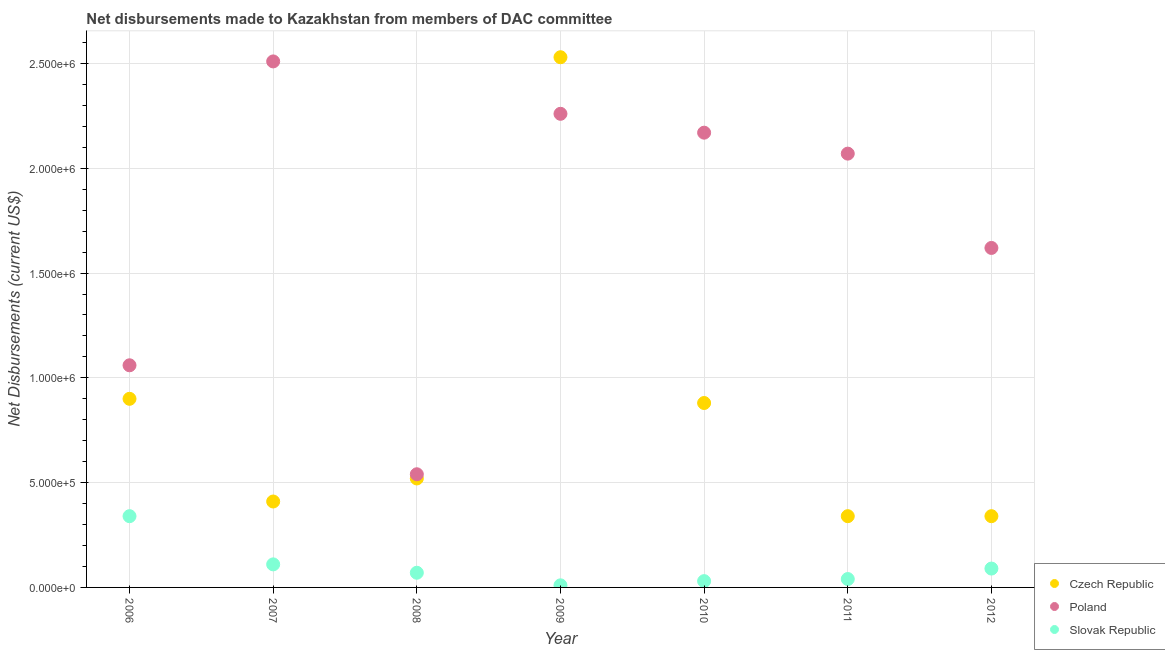How many different coloured dotlines are there?
Ensure brevity in your answer.  3. Is the number of dotlines equal to the number of legend labels?
Your answer should be very brief. Yes. What is the net disbursements made by poland in 2011?
Give a very brief answer. 2.07e+06. Across all years, what is the maximum net disbursements made by czech republic?
Make the answer very short. 2.53e+06. Across all years, what is the minimum net disbursements made by slovak republic?
Ensure brevity in your answer.  10000. In which year was the net disbursements made by czech republic maximum?
Offer a very short reply. 2009. In which year was the net disbursements made by poland minimum?
Your response must be concise. 2008. What is the total net disbursements made by czech republic in the graph?
Make the answer very short. 5.92e+06. What is the difference between the net disbursements made by poland in 2007 and that in 2010?
Your answer should be compact. 3.40e+05. What is the difference between the net disbursements made by czech republic in 2006 and the net disbursements made by poland in 2008?
Offer a terse response. 3.60e+05. What is the average net disbursements made by czech republic per year?
Offer a terse response. 8.46e+05. In the year 2011, what is the difference between the net disbursements made by slovak republic and net disbursements made by poland?
Ensure brevity in your answer.  -2.03e+06. What is the ratio of the net disbursements made by poland in 2007 to that in 2008?
Offer a very short reply. 4.65. Is the net disbursements made by slovak republic in 2007 less than that in 2009?
Keep it short and to the point. No. Is the difference between the net disbursements made by slovak republic in 2008 and 2012 greater than the difference between the net disbursements made by poland in 2008 and 2012?
Ensure brevity in your answer.  Yes. What is the difference between the highest and the second highest net disbursements made by czech republic?
Make the answer very short. 1.63e+06. What is the difference between the highest and the lowest net disbursements made by czech republic?
Ensure brevity in your answer.  2.19e+06. In how many years, is the net disbursements made by poland greater than the average net disbursements made by poland taken over all years?
Keep it short and to the point. 4. Is it the case that in every year, the sum of the net disbursements made by czech republic and net disbursements made by poland is greater than the net disbursements made by slovak republic?
Your answer should be compact. Yes. Does the net disbursements made by slovak republic monotonically increase over the years?
Your response must be concise. No. How many years are there in the graph?
Provide a succinct answer. 7. Are the values on the major ticks of Y-axis written in scientific E-notation?
Offer a terse response. Yes. Does the graph contain grids?
Keep it short and to the point. Yes. How are the legend labels stacked?
Keep it short and to the point. Vertical. What is the title of the graph?
Your response must be concise. Net disbursements made to Kazakhstan from members of DAC committee. Does "Ages 20-60" appear as one of the legend labels in the graph?
Your answer should be compact. No. What is the label or title of the X-axis?
Offer a very short reply. Year. What is the label or title of the Y-axis?
Your answer should be very brief. Net Disbursements (current US$). What is the Net Disbursements (current US$) of Czech Republic in 2006?
Keep it short and to the point. 9.00e+05. What is the Net Disbursements (current US$) of Poland in 2006?
Make the answer very short. 1.06e+06. What is the Net Disbursements (current US$) of Slovak Republic in 2006?
Provide a short and direct response. 3.40e+05. What is the Net Disbursements (current US$) of Czech Republic in 2007?
Your answer should be very brief. 4.10e+05. What is the Net Disbursements (current US$) in Poland in 2007?
Offer a terse response. 2.51e+06. What is the Net Disbursements (current US$) in Slovak Republic in 2007?
Ensure brevity in your answer.  1.10e+05. What is the Net Disbursements (current US$) in Czech Republic in 2008?
Give a very brief answer. 5.20e+05. What is the Net Disbursements (current US$) in Poland in 2008?
Your answer should be compact. 5.40e+05. What is the Net Disbursements (current US$) of Czech Republic in 2009?
Offer a terse response. 2.53e+06. What is the Net Disbursements (current US$) of Poland in 2009?
Your answer should be very brief. 2.26e+06. What is the Net Disbursements (current US$) of Czech Republic in 2010?
Your response must be concise. 8.80e+05. What is the Net Disbursements (current US$) in Poland in 2010?
Your response must be concise. 2.17e+06. What is the Net Disbursements (current US$) in Slovak Republic in 2010?
Your answer should be compact. 3.00e+04. What is the Net Disbursements (current US$) in Poland in 2011?
Offer a terse response. 2.07e+06. What is the Net Disbursements (current US$) in Czech Republic in 2012?
Offer a terse response. 3.40e+05. What is the Net Disbursements (current US$) in Poland in 2012?
Offer a very short reply. 1.62e+06. Across all years, what is the maximum Net Disbursements (current US$) in Czech Republic?
Offer a terse response. 2.53e+06. Across all years, what is the maximum Net Disbursements (current US$) of Poland?
Offer a very short reply. 2.51e+06. Across all years, what is the maximum Net Disbursements (current US$) in Slovak Republic?
Your response must be concise. 3.40e+05. Across all years, what is the minimum Net Disbursements (current US$) in Poland?
Offer a terse response. 5.40e+05. What is the total Net Disbursements (current US$) in Czech Republic in the graph?
Offer a very short reply. 5.92e+06. What is the total Net Disbursements (current US$) of Poland in the graph?
Your response must be concise. 1.22e+07. What is the total Net Disbursements (current US$) in Slovak Republic in the graph?
Provide a succinct answer. 6.90e+05. What is the difference between the Net Disbursements (current US$) of Czech Republic in 2006 and that in 2007?
Your answer should be compact. 4.90e+05. What is the difference between the Net Disbursements (current US$) in Poland in 2006 and that in 2007?
Make the answer very short. -1.45e+06. What is the difference between the Net Disbursements (current US$) of Poland in 2006 and that in 2008?
Give a very brief answer. 5.20e+05. What is the difference between the Net Disbursements (current US$) in Czech Republic in 2006 and that in 2009?
Offer a terse response. -1.63e+06. What is the difference between the Net Disbursements (current US$) of Poland in 2006 and that in 2009?
Your response must be concise. -1.20e+06. What is the difference between the Net Disbursements (current US$) of Czech Republic in 2006 and that in 2010?
Make the answer very short. 2.00e+04. What is the difference between the Net Disbursements (current US$) in Poland in 2006 and that in 2010?
Offer a terse response. -1.11e+06. What is the difference between the Net Disbursements (current US$) in Czech Republic in 2006 and that in 2011?
Provide a succinct answer. 5.60e+05. What is the difference between the Net Disbursements (current US$) in Poland in 2006 and that in 2011?
Offer a terse response. -1.01e+06. What is the difference between the Net Disbursements (current US$) in Slovak Republic in 2006 and that in 2011?
Your answer should be compact. 3.00e+05. What is the difference between the Net Disbursements (current US$) in Czech Republic in 2006 and that in 2012?
Keep it short and to the point. 5.60e+05. What is the difference between the Net Disbursements (current US$) in Poland in 2006 and that in 2012?
Ensure brevity in your answer.  -5.60e+05. What is the difference between the Net Disbursements (current US$) in Poland in 2007 and that in 2008?
Your answer should be very brief. 1.97e+06. What is the difference between the Net Disbursements (current US$) in Slovak Republic in 2007 and that in 2008?
Offer a terse response. 4.00e+04. What is the difference between the Net Disbursements (current US$) of Czech Republic in 2007 and that in 2009?
Keep it short and to the point. -2.12e+06. What is the difference between the Net Disbursements (current US$) in Poland in 2007 and that in 2009?
Ensure brevity in your answer.  2.50e+05. What is the difference between the Net Disbursements (current US$) of Slovak Republic in 2007 and that in 2009?
Your response must be concise. 1.00e+05. What is the difference between the Net Disbursements (current US$) in Czech Republic in 2007 and that in 2010?
Make the answer very short. -4.70e+05. What is the difference between the Net Disbursements (current US$) in Poland in 2007 and that in 2010?
Keep it short and to the point. 3.40e+05. What is the difference between the Net Disbursements (current US$) of Slovak Republic in 2007 and that in 2010?
Offer a very short reply. 8.00e+04. What is the difference between the Net Disbursements (current US$) of Czech Republic in 2007 and that in 2011?
Provide a short and direct response. 7.00e+04. What is the difference between the Net Disbursements (current US$) in Poland in 2007 and that in 2012?
Your response must be concise. 8.90e+05. What is the difference between the Net Disbursements (current US$) of Czech Republic in 2008 and that in 2009?
Keep it short and to the point. -2.01e+06. What is the difference between the Net Disbursements (current US$) in Poland in 2008 and that in 2009?
Your answer should be compact. -1.72e+06. What is the difference between the Net Disbursements (current US$) of Slovak Republic in 2008 and that in 2009?
Make the answer very short. 6.00e+04. What is the difference between the Net Disbursements (current US$) of Czech Republic in 2008 and that in 2010?
Give a very brief answer. -3.60e+05. What is the difference between the Net Disbursements (current US$) of Poland in 2008 and that in 2010?
Provide a short and direct response. -1.63e+06. What is the difference between the Net Disbursements (current US$) in Czech Republic in 2008 and that in 2011?
Keep it short and to the point. 1.80e+05. What is the difference between the Net Disbursements (current US$) of Poland in 2008 and that in 2011?
Provide a short and direct response. -1.53e+06. What is the difference between the Net Disbursements (current US$) of Czech Republic in 2008 and that in 2012?
Your answer should be very brief. 1.80e+05. What is the difference between the Net Disbursements (current US$) of Poland in 2008 and that in 2012?
Provide a short and direct response. -1.08e+06. What is the difference between the Net Disbursements (current US$) in Slovak Republic in 2008 and that in 2012?
Ensure brevity in your answer.  -2.00e+04. What is the difference between the Net Disbursements (current US$) of Czech Republic in 2009 and that in 2010?
Offer a very short reply. 1.65e+06. What is the difference between the Net Disbursements (current US$) in Poland in 2009 and that in 2010?
Offer a terse response. 9.00e+04. What is the difference between the Net Disbursements (current US$) in Slovak Republic in 2009 and that in 2010?
Provide a short and direct response. -2.00e+04. What is the difference between the Net Disbursements (current US$) in Czech Republic in 2009 and that in 2011?
Give a very brief answer. 2.19e+06. What is the difference between the Net Disbursements (current US$) in Czech Republic in 2009 and that in 2012?
Offer a terse response. 2.19e+06. What is the difference between the Net Disbursements (current US$) in Poland in 2009 and that in 2012?
Offer a terse response. 6.40e+05. What is the difference between the Net Disbursements (current US$) in Czech Republic in 2010 and that in 2011?
Offer a terse response. 5.40e+05. What is the difference between the Net Disbursements (current US$) of Czech Republic in 2010 and that in 2012?
Your answer should be very brief. 5.40e+05. What is the difference between the Net Disbursements (current US$) in Slovak Republic in 2010 and that in 2012?
Your response must be concise. -6.00e+04. What is the difference between the Net Disbursements (current US$) of Poland in 2011 and that in 2012?
Give a very brief answer. 4.50e+05. What is the difference between the Net Disbursements (current US$) of Czech Republic in 2006 and the Net Disbursements (current US$) of Poland in 2007?
Your answer should be compact. -1.61e+06. What is the difference between the Net Disbursements (current US$) in Czech Republic in 2006 and the Net Disbursements (current US$) in Slovak Republic in 2007?
Give a very brief answer. 7.90e+05. What is the difference between the Net Disbursements (current US$) in Poland in 2006 and the Net Disbursements (current US$) in Slovak Republic in 2007?
Provide a short and direct response. 9.50e+05. What is the difference between the Net Disbursements (current US$) of Czech Republic in 2006 and the Net Disbursements (current US$) of Slovak Republic in 2008?
Keep it short and to the point. 8.30e+05. What is the difference between the Net Disbursements (current US$) of Poland in 2006 and the Net Disbursements (current US$) of Slovak Republic in 2008?
Offer a very short reply. 9.90e+05. What is the difference between the Net Disbursements (current US$) of Czech Republic in 2006 and the Net Disbursements (current US$) of Poland in 2009?
Give a very brief answer. -1.36e+06. What is the difference between the Net Disbursements (current US$) of Czech Republic in 2006 and the Net Disbursements (current US$) of Slovak Republic in 2009?
Make the answer very short. 8.90e+05. What is the difference between the Net Disbursements (current US$) in Poland in 2006 and the Net Disbursements (current US$) in Slovak Republic in 2009?
Your answer should be compact. 1.05e+06. What is the difference between the Net Disbursements (current US$) in Czech Republic in 2006 and the Net Disbursements (current US$) in Poland in 2010?
Your answer should be compact. -1.27e+06. What is the difference between the Net Disbursements (current US$) of Czech Republic in 2006 and the Net Disbursements (current US$) of Slovak Republic in 2010?
Give a very brief answer. 8.70e+05. What is the difference between the Net Disbursements (current US$) in Poland in 2006 and the Net Disbursements (current US$) in Slovak Republic in 2010?
Offer a very short reply. 1.03e+06. What is the difference between the Net Disbursements (current US$) of Czech Republic in 2006 and the Net Disbursements (current US$) of Poland in 2011?
Offer a terse response. -1.17e+06. What is the difference between the Net Disbursements (current US$) of Czech Republic in 2006 and the Net Disbursements (current US$) of Slovak Republic in 2011?
Your answer should be compact. 8.60e+05. What is the difference between the Net Disbursements (current US$) of Poland in 2006 and the Net Disbursements (current US$) of Slovak Republic in 2011?
Offer a terse response. 1.02e+06. What is the difference between the Net Disbursements (current US$) in Czech Republic in 2006 and the Net Disbursements (current US$) in Poland in 2012?
Provide a short and direct response. -7.20e+05. What is the difference between the Net Disbursements (current US$) of Czech Republic in 2006 and the Net Disbursements (current US$) of Slovak Republic in 2012?
Provide a succinct answer. 8.10e+05. What is the difference between the Net Disbursements (current US$) of Poland in 2006 and the Net Disbursements (current US$) of Slovak Republic in 2012?
Provide a succinct answer. 9.70e+05. What is the difference between the Net Disbursements (current US$) in Czech Republic in 2007 and the Net Disbursements (current US$) in Poland in 2008?
Ensure brevity in your answer.  -1.30e+05. What is the difference between the Net Disbursements (current US$) in Poland in 2007 and the Net Disbursements (current US$) in Slovak Republic in 2008?
Your response must be concise. 2.44e+06. What is the difference between the Net Disbursements (current US$) in Czech Republic in 2007 and the Net Disbursements (current US$) in Poland in 2009?
Give a very brief answer. -1.85e+06. What is the difference between the Net Disbursements (current US$) of Poland in 2007 and the Net Disbursements (current US$) of Slovak Republic in 2009?
Provide a succinct answer. 2.50e+06. What is the difference between the Net Disbursements (current US$) of Czech Republic in 2007 and the Net Disbursements (current US$) of Poland in 2010?
Make the answer very short. -1.76e+06. What is the difference between the Net Disbursements (current US$) of Czech Republic in 2007 and the Net Disbursements (current US$) of Slovak Republic in 2010?
Your response must be concise. 3.80e+05. What is the difference between the Net Disbursements (current US$) of Poland in 2007 and the Net Disbursements (current US$) of Slovak Republic in 2010?
Provide a succinct answer. 2.48e+06. What is the difference between the Net Disbursements (current US$) of Czech Republic in 2007 and the Net Disbursements (current US$) of Poland in 2011?
Provide a short and direct response. -1.66e+06. What is the difference between the Net Disbursements (current US$) in Poland in 2007 and the Net Disbursements (current US$) in Slovak Republic in 2011?
Offer a terse response. 2.47e+06. What is the difference between the Net Disbursements (current US$) in Czech Republic in 2007 and the Net Disbursements (current US$) in Poland in 2012?
Your response must be concise. -1.21e+06. What is the difference between the Net Disbursements (current US$) of Poland in 2007 and the Net Disbursements (current US$) of Slovak Republic in 2012?
Offer a very short reply. 2.42e+06. What is the difference between the Net Disbursements (current US$) of Czech Republic in 2008 and the Net Disbursements (current US$) of Poland in 2009?
Provide a succinct answer. -1.74e+06. What is the difference between the Net Disbursements (current US$) in Czech Republic in 2008 and the Net Disbursements (current US$) in Slovak Republic in 2009?
Provide a short and direct response. 5.10e+05. What is the difference between the Net Disbursements (current US$) of Poland in 2008 and the Net Disbursements (current US$) of Slovak Republic in 2009?
Give a very brief answer. 5.30e+05. What is the difference between the Net Disbursements (current US$) in Czech Republic in 2008 and the Net Disbursements (current US$) in Poland in 2010?
Provide a short and direct response. -1.65e+06. What is the difference between the Net Disbursements (current US$) in Poland in 2008 and the Net Disbursements (current US$) in Slovak Republic in 2010?
Give a very brief answer. 5.10e+05. What is the difference between the Net Disbursements (current US$) in Czech Republic in 2008 and the Net Disbursements (current US$) in Poland in 2011?
Make the answer very short. -1.55e+06. What is the difference between the Net Disbursements (current US$) in Czech Republic in 2008 and the Net Disbursements (current US$) in Poland in 2012?
Your answer should be very brief. -1.10e+06. What is the difference between the Net Disbursements (current US$) of Czech Republic in 2008 and the Net Disbursements (current US$) of Slovak Republic in 2012?
Ensure brevity in your answer.  4.30e+05. What is the difference between the Net Disbursements (current US$) of Poland in 2008 and the Net Disbursements (current US$) of Slovak Republic in 2012?
Keep it short and to the point. 4.50e+05. What is the difference between the Net Disbursements (current US$) of Czech Republic in 2009 and the Net Disbursements (current US$) of Poland in 2010?
Offer a terse response. 3.60e+05. What is the difference between the Net Disbursements (current US$) of Czech Republic in 2009 and the Net Disbursements (current US$) of Slovak Republic in 2010?
Offer a terse response. 2.50e+06. What is the difference between the Net Disbursements (current US$) of Poland in 2009 and the Net Disbursements (current US$) of Slovak Republic in 2010?
Provide a succinct answer. 2.23e+06. What is the difference between the Net Disbursements (current US$) of Czech Republic in 2009 and the Net Disbursements (current US$) of Poland in 2011?
Offer a very short reply. 4.60e+05. What is the difference between the Net Disbursements (current US$) in Czech Republic in 2009 and the Net Disbursements (current US$) in Slovak Republic in 2011?
Offer a terse response. 2.49e+06. What is the difference between the Net Disbursements (current US$) in Poland in 2009 and the Net Disbursements (current US$) in Slovak Republic in 2011?
Provide a succinct answer. 2.22e+06. What is the difference between the Net Disbursements (current US$) of Czech Republic in 2009 and the Net Disbursements (current US$) of Poland in 2012?
Make the answer very short. 9.10e+05. What is the difference between the Net Disbursements (current US$) of Czech Republic in 2009 and the Net Disbursements (current US$) of Slovak Republic in 2012?
Make the answer very short. 2.44e+06. What is the difference between the Net Disbursements (current US$) of Poland in 2009 and the Net Disbursements (current US$) of Slovak Republic in 2012?
Make the answer very short. 2.17e+06. What is the difference between the Net Disbursements (current US$) in Czech Republic in 2010 and the Net Disbursements (current US$) in Poland in 2011?
Your answer should be very brief. -1.19e+06. What is the difference between the Net Disbursements (current US$) of Czech Republic in 2010 and the Net Disbursements (current US$) of Slovak Republic in 2011?
Give a very brief answer. 8.40e+05. What is the difference between the Net Disbursements (current US$) in Poland in 2010 and the Net Disbursements (current US$) in Slovak Republic in 2011?
Make the answer very short. 2.13e+06. What is the difference between the Net Disbursements (current US$) of Czech Republic in 2010 and the Net Disbursements (current US$) of Poland in 2012?
Your answer should be very brief. -7.40e+05. What is the difference between the Net Disbursements (current US$) of Czech Republic in 2010 and the Net Disbursements (current US$) of Slovak Republic in 2012?
Your answer should be very brief. 7.90e+05. What is the difference between the Net Disbursements (current US$) in Poland in 2010 and the Net Disbursements (current US$) in Slovak Republic in 2012?
Your answer should be compact. 2.08e+06. What is the difference between the Net Disbursements (current US$) in Czech Republic in 2011 and the Net Disbursements (current US$) in Poland in 2012?
Ensure brevity in your answer.  -1.28e+06. What is the difference between the Net Disbursements (current US$) of Czech Republic in 2011 and the Net Disbursements (current US$) of Slovak Republic in 2012?
Your answer should be compact. 2.50e+05. What is the difference between the Net Disbursements (current US$) in Poland in 2011 and the Net Disbursements (current US$) in Slovak Republic in 2012?
Ensure brevity in your answer.  1.98e+06. What is the average Net Disbursements (current US$) of Czech Republic per year?
Provide a succinct answer. 8.46e+05. What is the average Net Disbursements (current US$) of Poland per year?
Offer a terse response. 1.75e+06. What is the average Net Disbursements (current US$) of Slovak Republic per year?
Your answer should be very brief. 9.86e+04. In the year 2006, what is the difference between the Net Disbursements (current US$) of Czech Republic and Net Disbursements (current US$) of Slovak Republic?
Your answer should be very brief. 5.60e+05. In the year 2006, what is the difference between the Net Disbursements (current US$) in Poland and Net Disbursements (current US$) in Slovak Republic?
Keep it short and to the point. 7.20e+05. In the year 2007, what is the difference between the Net Disbursements (current US$) of Czech Republic and Net Disbursements (current US$) of Poland?
Offer a very short reply. -2.10e+06. In the year 2007, what is the difference between the Net Disbursements (current US$) of Poland and Net Disbursements (current US$) of Slovak Republic?
Provide a succinct answer. 2.40e+06. In the year 2008, what is the difference between the Net Disbursements (current US$) of Czech Republic and Net Disbursements (current US$) of Slovak Republic?
Your answer should be compact. 4.50e+05. In the year 2008, what is the difference between the Net Disbursements (current US$) of Poland and Net Disbursements (current US$) of Slovak Republic?
Offer a very short reply. 4.70e+05. In the year 2009, what is the difference between the Net Disbursements (current US$) in Czech Republic and Net Disbursements (current US$) in Slovak Republic?
Offer a very short reply. 2.52e+06. In the year 2009, what is the difference between the Net Disbursements (current US$) of Poland and Net Disbursements (current US$) of Slovak Republic?
Your answer should be very brief. 2.25e+06. In the year 2010, what is the difference between the Net Disbursements (current US$) of Czech Republic and Net Disbursements (current US$) of Poland?
Provide a short and direct response. -1.29e+06. In the year 2010, what is the difference between the Net Disbursements (current US$) of Czech Republic and Net Disbursements (current US$) of Slovak Republic?
Ensure brevity in your answer.  8.50e+05. In the year 2010, what is the difference between the Net Disbursements (current US$) of Poland and Net Disbursements (current US$) of Slovak Republic?
Ensure brevity in your answer.  2.14e+06. In the year 2011, what is the difference between the Net Disbursements (current US$) of Czech Republic and Net Disbursements (current US$) of Poland?
Make the answer very short. -1.73e+06. In the year 2011, what is the difference between the Net Disbursements (current US$) of Poland and Net Disbursements (current US$) of Slovak Republic?
Make the answer very short. 2.03e+06. In the year 2012, what is the difference between the Net Disbursements (current US$) in Czech Republic and Net Disbursements (current US$) in Poland?
Keep it short and to the point. -1.28e+06. In the year 2012, what is the difference between the Net Disbursements (current US$) in Poland and Net Disbursements (current US$) in Slovak Republic?
Your response must be concise. 1.53e+06. What is the ratio of the Net Disbursements (current US$) in Czech Republic in 2006 to that in 2007?
Your answer should be very brief. 2.2. What is the ratio of the Net Disbursements (current US$) in Poland in 2006 to that in 2007?
Ensure brevity in your answer.  0.42. What is the ratio of the Net Disbursements (current US$) of Slovak Republic in 2006 to that in 2007?
Offer a terse response. 3.09. What is the ratio of the Net Disbursements (current US$) in Czech Republic in 2006 to that in 2008?
Provide a short and direct response. 1.73. What is the ratio of the Net Disbursements (current US$) in Poland in 2006 to that in 2008?
Your answer should be very brief. 1.96. What is the ratio of the Net Disbursements (current US$) of Slovak Republic in 2006 to that in 2008?
Your answer should be very brief. 4.86. What is the ratio of the Net Disbursements (current US$) in Czech Republic in 2006 to that in 2009?
Your answer should be very brief. 0.36. What is the ratio of the Net Disbursements (current US$) in Poland in 2006 to that in 2009?
Offer a very short reply. 0.47. What is the ratio of the Net Disbursements (current US$) in Slovak Republic in 2006 to that in 2009?
Give a very brief answer. 34. What is the ratio of the Net Disbursements (current US$) in Czech Republic in 2006 to that in 2010?
Make the answer very short. 1.02. What is the ratio of the Net Disbursements (current US$) of Poland in 2006 to that in 2010?
Make the answer very short. 0.49. What is the ratio of the Net Disbursements (current US$) in Slovak Republic in 2006 to that in 2010?
Give a very brief answer. 11.33. What is the ratio of the Net Disbursements (current US$) of Czech Republic in 2006 to that in 2011?
Make the answer very short. 2.65. What is the ratio of the Net Disbursements (current US$) in Poland in 2006 to that in 2011?
Offer a terse response. 0.51. What is the ratio of the Net Disbursements (current US$) in Slovak Republic in 2006 to that in 2011?
Ensure brevity in your answer.  8.5. What is the ratio of the Net Disbursements (current US$) of Czech Republic in 2006 to that in 2012?
Provide a succinct answer. 2.65. What is the ratio of the Net Disbursements (current US$) of Poland in 2006 to that in 2012?
Provide a succinct answer. 0.65. What is the ratio of the Net Disbursements (current US$) of Slovak Republic in 2006 to that in 2012?
Make the answer very short. 3.78. What is the ratio of the Net Disbursements (current US$) in Czech Republic in 2007 to that in 2008?
Give a very brief answer. 0.79. What is the ratio of the Net Disbursements (current US$) of Poland in 2007 to that in 2008?
Give a very brief answer. 4.65. What is the ratio of the Net Disbursements (current US$) of Slovak Republic in 2007 to that in 2008?
Your answer should be very brief. 1.57. What is the ratio of the Net Disbursements (current US$) in Czech Republic in 2007 to that in 2009?
Provide a succinct answer. 0.16. What is the ratio of the Net Disbursements (current US$) of Poland in 2007 to that in 2009?
Your answer should be very brief. 1.11. What is the ratio of the Net Disbursements (current US$) in Slovak Republic in 2007 to that in 2009?
Your answer should be very brief. 11. What is the ratio of the Net Disbursements (current US$) in Czech Republic in 2007 to that in 2010?
Offer a terse response. 0.47. What is the ratio of the Net Disbursements (current US$) of Poland in 2007 to that in 2010?
Your answer should be very brief. 1.16. What is the ratio of the Net Disbursements (current US$) in Slovak Republic in 2007 to that in 2010?
Make the answer very short. 3.67. What is the ratio of the Net Disbursements (current US$) of Czech Republic in 2007 to that in 2011?
Give a very brief answer. 1.21. What is the ratio of the Net Disbursements (current US$) in Poland in 2007 to that in 2011?
Give a very brief answer. 1.21. What is the ratio of the Net Disbursements (current US$) in Slovak Republic in 2007 to that in 2011?
Make the answer very short. 2.75. What is the ratio of the Net Disbursements (current US$) of Czech Republic in 2007 to that in 2012?
Ensure brevity in your answer.  1.21. What is the ratio of the Net Disbursements (current US$) of Poland in 2007 to that in 2012?
Provide a short and direct response. 1.55. What is the ratio of the Net Disbursements (current US$) of Slovak Republic in 2007 to that in 2012?
Provide a short and direct response. 1.22. What is the ratio of the Net Disbursements (current US$) in Czech Republic in 2008 to that in 2009?
Offer a terse response. 0.21. What is the ratio of the Net Disbursements (current US$) in Poland in 2008 to that in 2009?
Make the answer very short. 0.24. What is the ratio of the Net Disbursements (current US$) of Slovak Republic in 2008 to that in 2009?
Offer a terse response. 7. What is the ratio of the Net Disbursements (current US$) of Czech Republic in 2008 to that in 2010?
Offer a terse response. 0.59. What is the ratio of the Net Disbursements (current US$) in Poland in 2008 to that in 2010?
Your answer should be compact. 0.25. What is the ratio of the Net Disbursements (current US$) in Slovak Republic in 2008 to that in 2010?
Offer a very short reply. 2.33. What is the ratio of the Net Disbursements (current US$) of Czech Republic in 2008 to that in 2011?
Your answer should be very brief. 1.53. What is the ratio of the Net Disbursements (current US$) of Poland in 2008 to that in 2011?
Make the answer very short. 0.26. What is the ratio of the Net Disbursements (current US$) in Czech Republic in 2008 to that in 2012?
Provide a succinct answer. 1.53. What is the ratio of the Net Disbursements (current US$) of Poland in 2008 to that in 2012?
Provide a succinct answer. 0.33. What is the ratio of the Net Disbursements (current US$) in Slovak Republic in 2008 to that in 2012?
Ensure brevity in your answer.  0.78. What is the ratio of the Net Disbursements (current US$) of Czech Republic in 2009 to that in 2010?
Keep it short and to the point. 2.88. What is the ratio of the Net Disbursements (current US$) in Poland in 2009 to that in 2010?
Offer a very short reply. 1.04. What is the ratio of the Net Disbursements (current US$) of Slovak Republic in 2009 to that in 2010?
Offer a very short reply. 0.33. What is the ratio of the Net Disbursements (current US$) of Czech Republic in 2009 to that in 2011?
Ensure brevity in your answer.  7.44. What is the ratio of the Net Disbursements (current US$) of Poland in 2009 to that in 2011?
Offer a terse response. 1.09. What is the ratio of the Net Disbursements (current US$) in Slovak Republic in 2009 to that in 2011?
Provide a short and direct response. 0.25. What is the ratio of the Net Disbursements (current US$) in Czech Republic in 2009 to that in 2012?
Provide a succinct answer. 7.44. What is the ratio of the Net Disbursements (current US$) of Poland in 2009 to that in 2012?
Make the answer very short. 1.4. What is the ratio of the Net Disbursements (current US$) of Slovak Republic in 2009 to that in 2012?
Keep it short and to the point. 0.11. What is the ratio of the Net Disbursements (current US$) of Czech Republic in 2010 to that in 2011?
Your answer should be compact. 2.59. What is the ratio of the Net Disbursements (current US$) in Poland in 2010 to that in 2011?
Provide a short and direct response. 1.05. What is the ratio of the Net Disbursements (current US$) in Czech Republic in 2010 to that in 2012?
Provide a succinct answer. 2.59. What is the ratio of the Net Disbursements (current US$) in Poland in 2010 to that in 2012?
Keep it short and to the point. 1.34. What is the ratio of the Net Disbursements (current US$) in Poland in 2011 to that in 2012?
Your answer should be very brief. 1.28. What is the ratio of the Net Disbursements (current US$) in Slovak Republic in 2011 to that in 2012?
Ensure brevity in your answer.  0.44. What is the difference between the highest and the second highest Net Disbursements (current US$) of Czech Republic?
Make the answer very short. 1.63e+06. What is the difference between the highest and the second highest Net Disbursements (current US$) of Poland?
Make the answer very short. 2.50e+05. What is the difference between the highest and the lowest Net Disbursements (current US$) in Czech Republic?
Keep it short and to the point. 2.19e+06. What is the difference between the highest and the lowest Net Disbursements (current US$) in Poland?
Ensure brevity in your answer.  1.97e+06. 